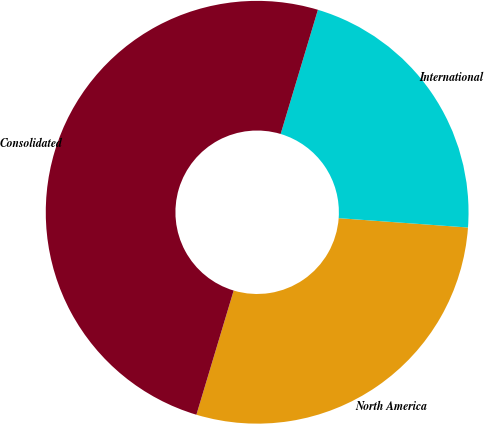Convert chart. <chart><loc_0><loc_0><loc_500><loc_500><pie_chart><fcel>North America<fcel>International<fcel>Consolidated<nl><fcel>28.49%<fcel>21.51%<fcel>50.0%<nl></chart> 